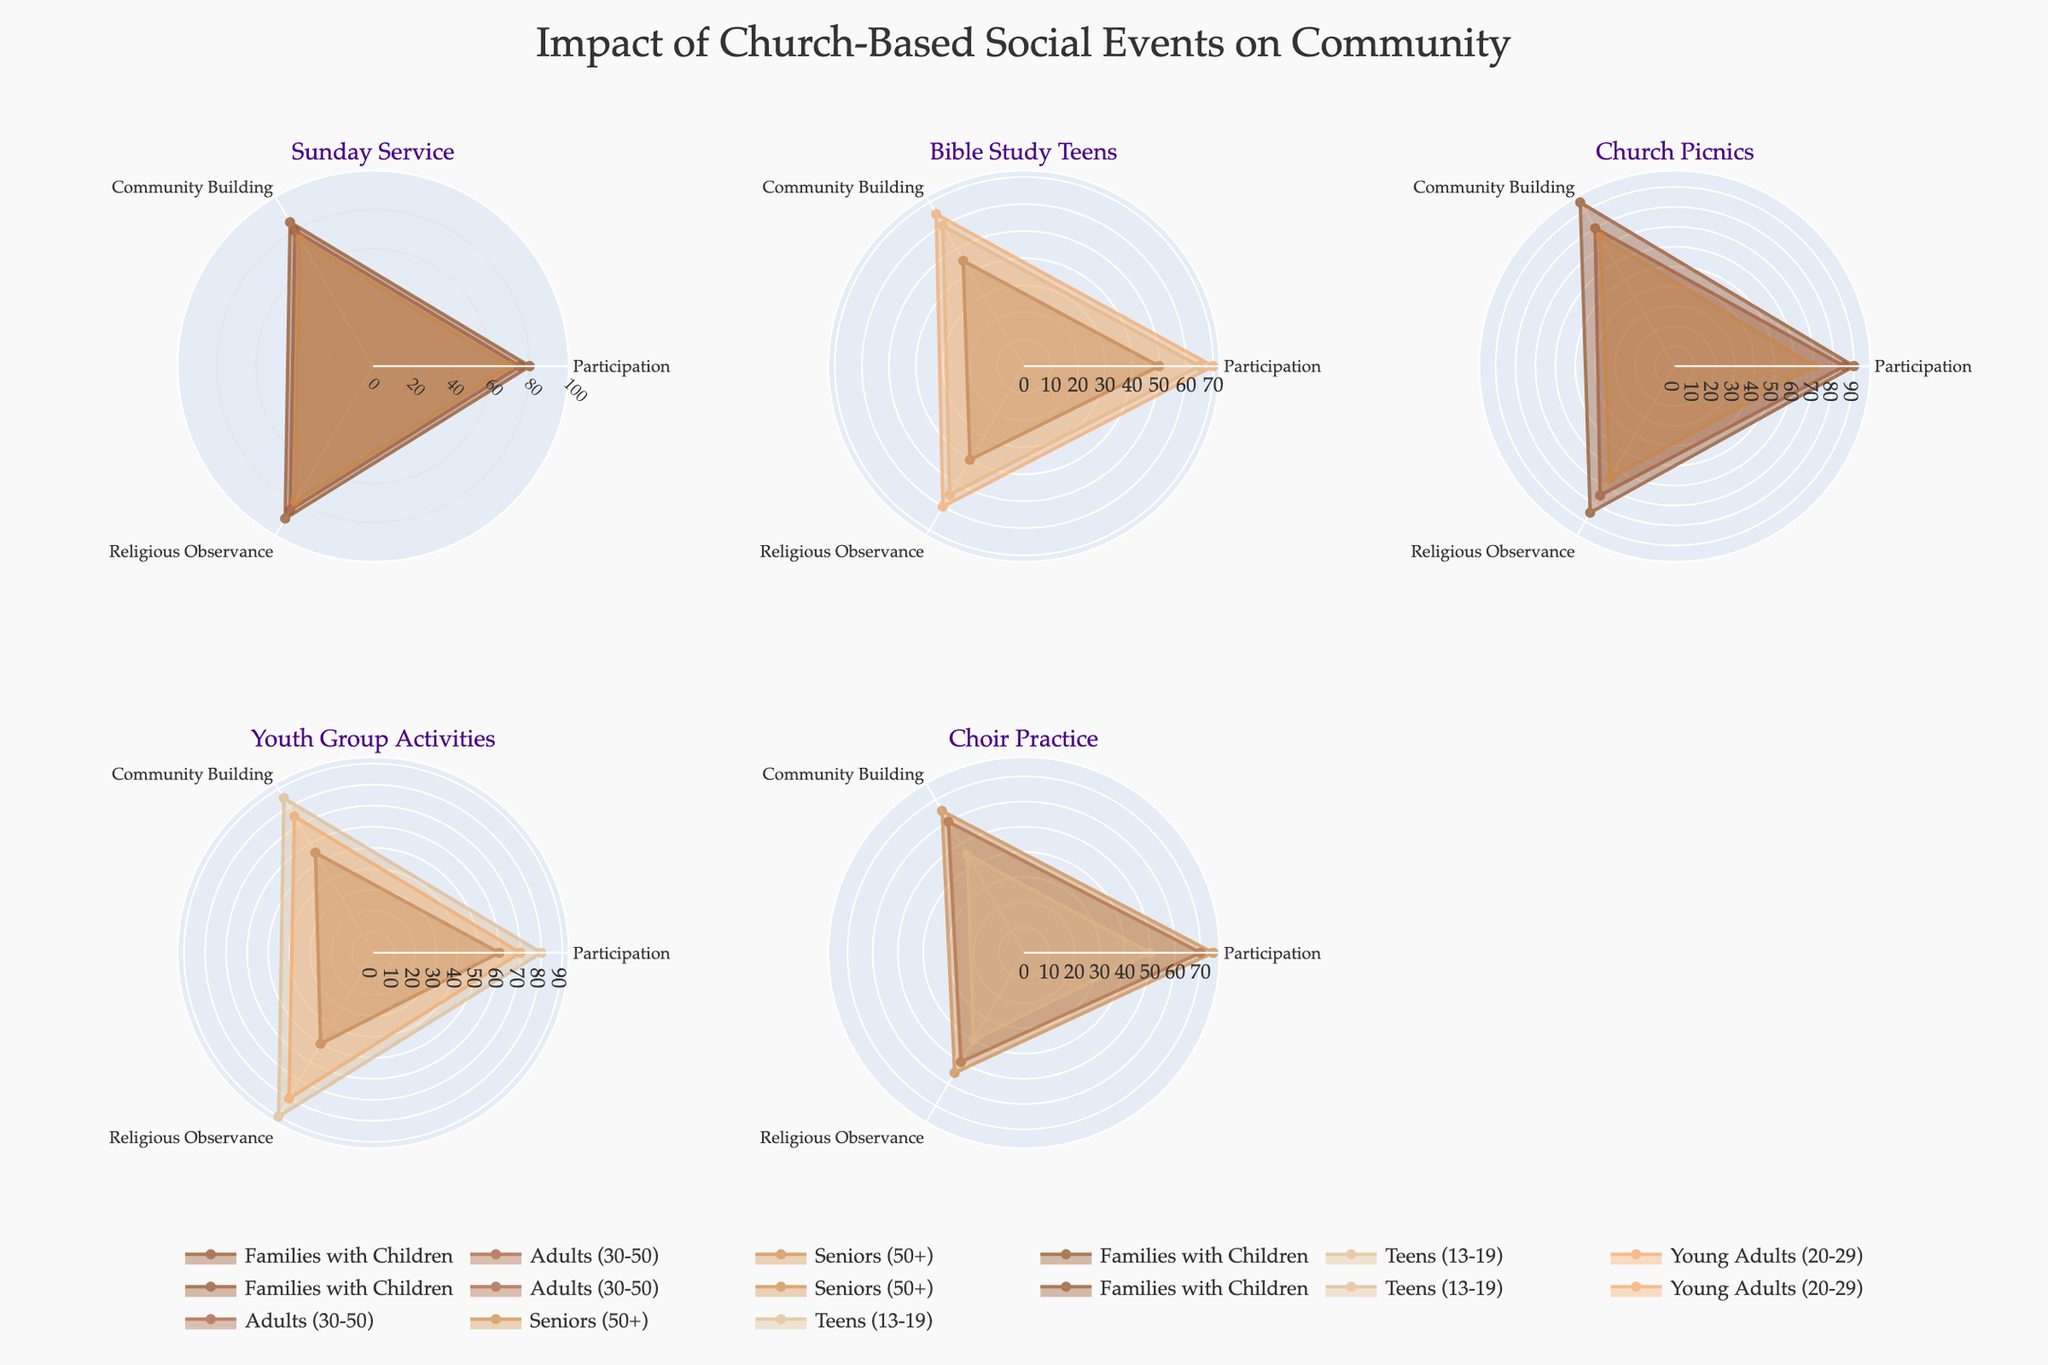What's the most common age group that participates in Sunday Service? By observing the subplot for Sunday Service, check which age group has the highest value for Participation. Families with Children have the highest value with 80%.
Answer: Families with Children How does Participation in Bible Study Teens compare between Teens and Families with Children? Check the Participation values for both age groups in the Bible Study Teens subplot. Teens have a Participation value of 65%, while Families with Children have 50%. So, Teens have higher Participation.
Answer: Teens have higher Participation Which event has the highest Community Building score for Adults (30-50)? Look through the subplots for each event and find the one where Adults (30-50) have the highest Community Building value. Church Picnics has the highest value for this age group, with a score of 80.
Answer: Church Picnics What is the average Religious Observance score across all events for Seniors (50+)? Find the Religious Observance scores for Seniors (50+) in each subplot and calculate the average. The scores are 80 (Sunday Service), 65 (Church Picnics), 55 (Choir Practice). The average is (80 + 65 + 55) / 3 = 66.67.
Answer: 66.67 Which event shows the lowest Participation for Teens (13-19)? Look at the Participation values for Teens in each subplot. The event with the lowest Participation for Teens is Choir Practice with a score of 50.
Answer: Choir Practice How do Community Building scores for Youth Group Activities compare between Young Adults (20-29) and Families with Children? Check the Community Building values in the Youth Group Activities subplot for these two age groups. Young Adults (20-29) have a score of 75, and Families with Children have 55. Young Adults have a higher score.
Answer: Young Adults have a higher score Which age group has the most consistent Participation scores across all events? Check the Participation scores for each age group in all subplots and see which group has the smallest variability (range). Families with Children participate most consistently with scores ranging from 50 to 90.
Answer: Families with Children Does the event with the highest Religious Observance score for Families with Children also have the highest Community Building score for the same age group? The highest Religious Observance score for Families with Children is 90 in Sunday Service. For Community Building, the highest for the same age group is 95 in Church Picnics. So, the answer is no.
Answer: No What is the difference in Community Building scores between Sunday Service and Church Picnics for Adults (30-50)? Check the Community Building values in the subplots for Sunday Service and Church Picnics for Adults (30-50). The values are 80 and 80 respectively, so the difference is 0.
Answer: 0 